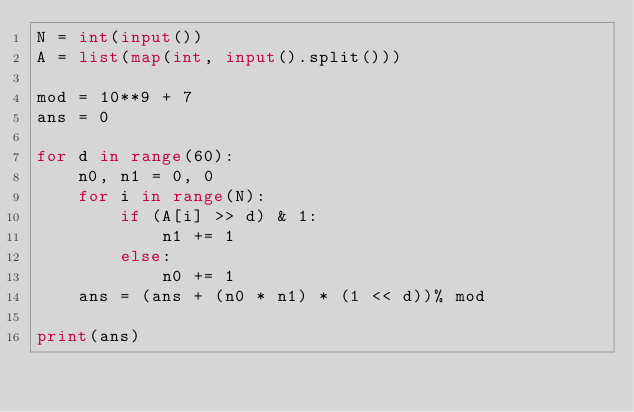Convert code to text. <code><loc_0><loc_0><loc_500><loc_500><_Python_>N = int(input())
A = list(map(int, input().split()))

mod = 10**9 + 7
ans = 0

for d in range(60):
    n0, n1 = 0, 0
    for i in range(N):
        if (A[i] >> d) & 1:
            n1 += 1
        else:
            n0 += 1
    ans = (ans + (n0 * n1) * (1 << d))% mod
    
print(ans)</code> 